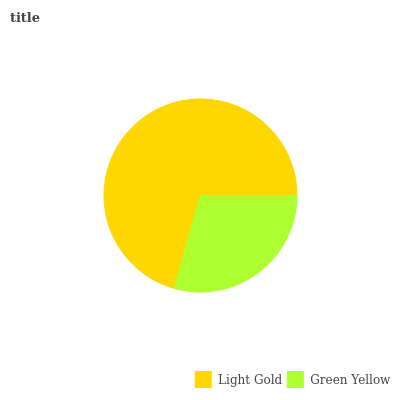Is Green Yellow the minimum?
Answer yes or no. Yes. Is Light Gold the maximum?
Answer yes or no. Yes. Is Green Yellow the maximum?
Answer yes or no. No. Is Light Gold greater than Green Yellow?
Answer yes or no. Yes. Is Green Yellow less than Light Gold?
Answer yes or no. Yes. Is Green Yellow greater than Light Gold?
Answer yes or no. No. Is Light Gold less than Green Yellow?
Answer yes or no. No. Is Light Gold the high median?
Answer yes or no. Yes. Is Green Yellow the low median?
Answer yes or no. Yes. Is Green Yellow the high median?
Answer yes or no. No. Is Light Gold the low median?
Answer yes or no. No. 